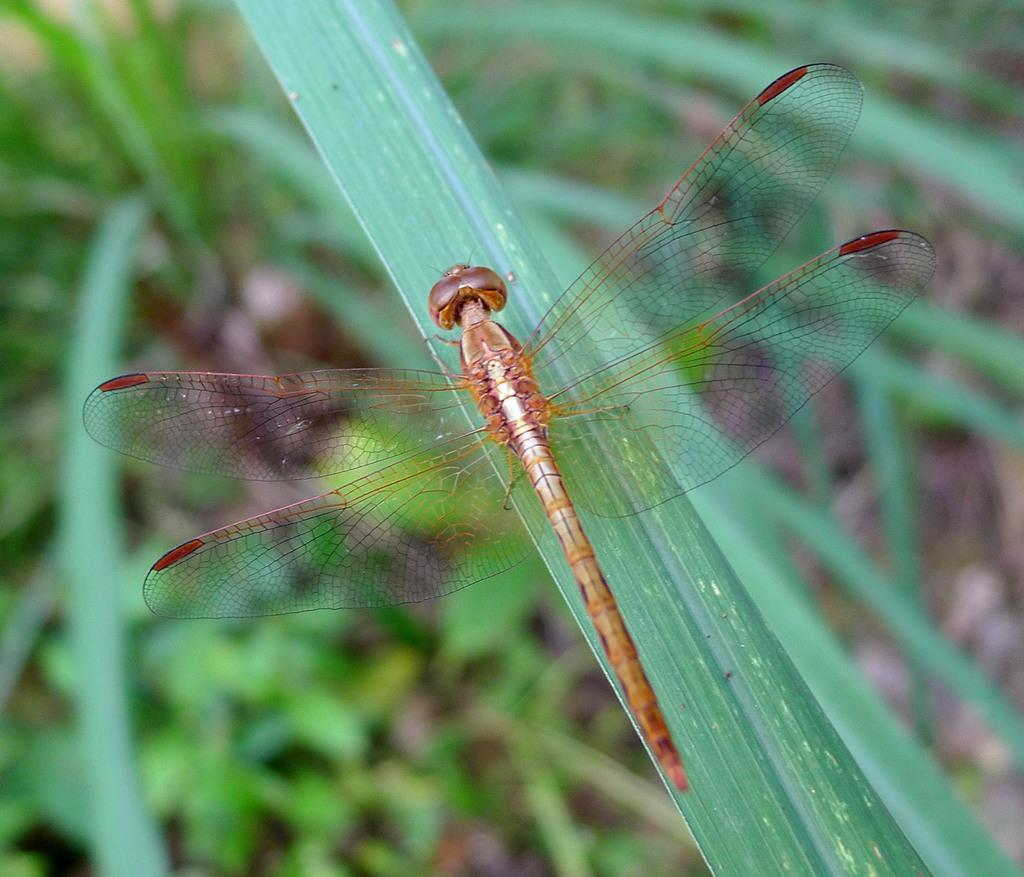What is on the leaf in the image? There is an insect on a leaf in the image. What can be seen in the background of the image? There are plants on the ground in the background. What type of furniture is visible in the image? There is no furniture present in the image; it features an insect on a leaf and plants in the background. How many wheels can be seen in the image? There are no wheels present in the image. 